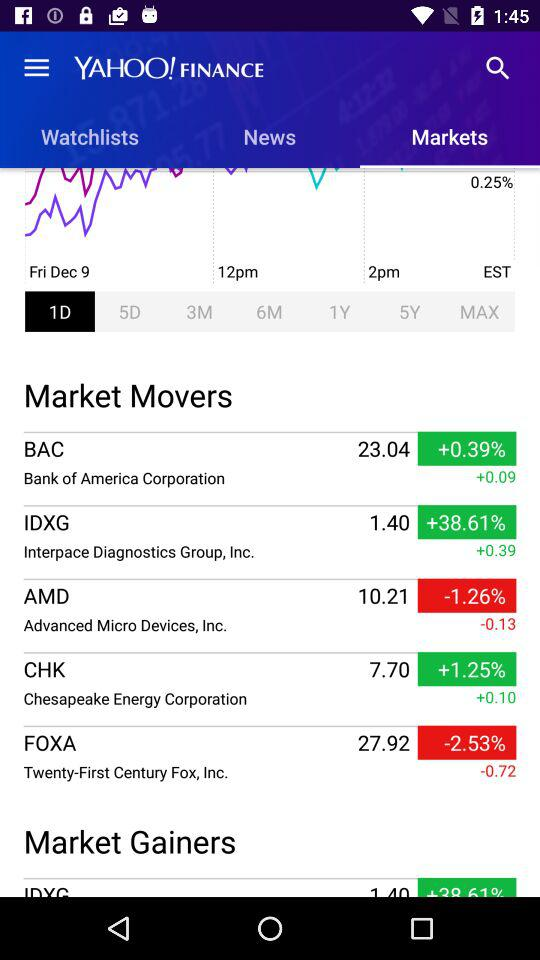What is the name of the application? The name of the application is "YAHOO! FINANCE". 